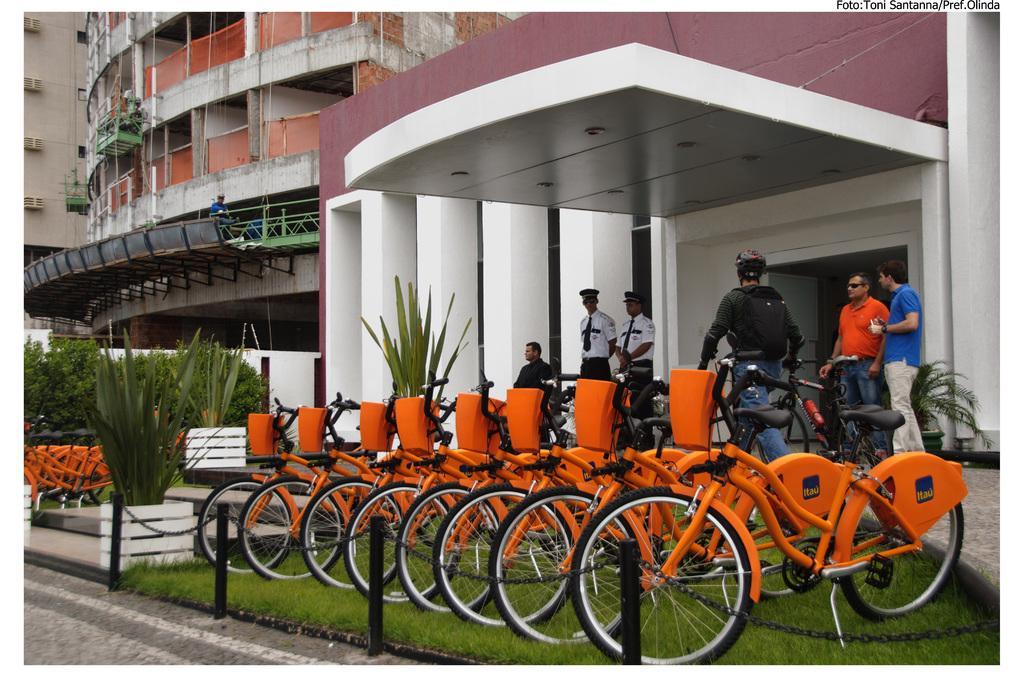Can you describe this image briefly? In the center of the image we can see cycles placed on the grass. At the bottom of the image we can see road and fencing. On the left side of the image we can see trees, plants, cycles. In the background we can see persons and buildings. 